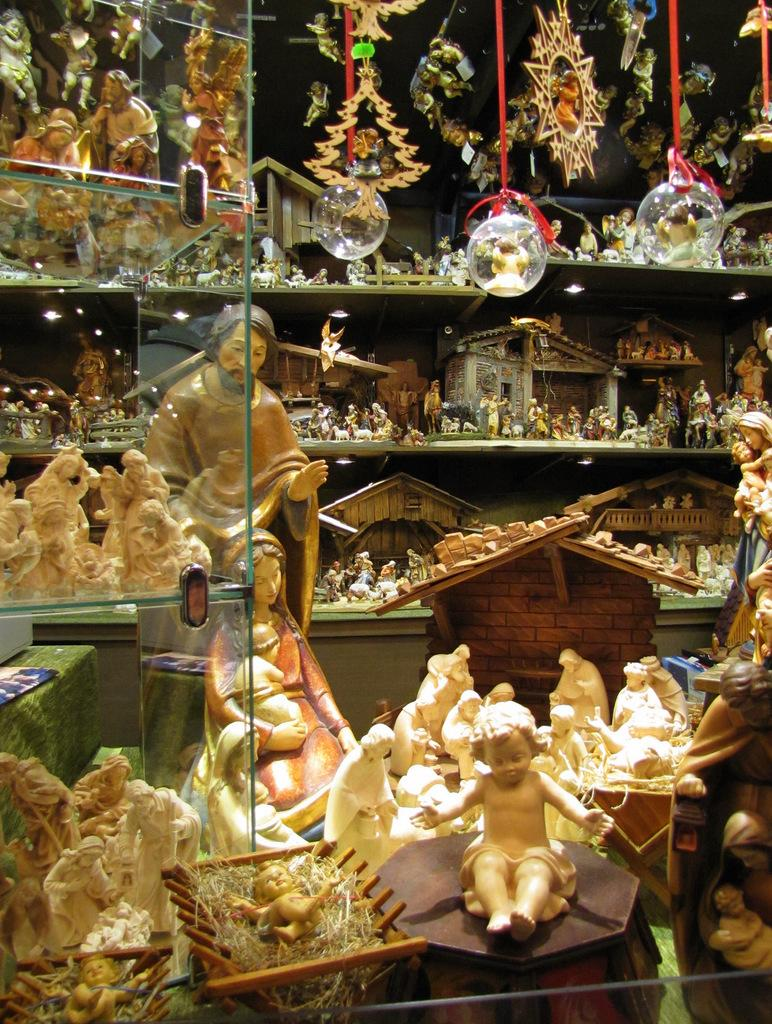What type of storage or display system is shown in the image? There are glass racks in the image. What is being displayed on the glass racks? The glass racks are full of sculptures and decoration items. How are the sculptures and decoration items arranged in the image? The sculptures and decoration items are hanged on the wall. What is the material of the wall beside the glass racks? There is a glass wall attached to the racks. Is there any other object or feature near the glass racks? Yes, there is a rock beside the glass racks. How many kitties are holding hands while distributing the sculptures in the image? There are no kitties present in the image, and the sculptures are already displayed on the glass racks. 